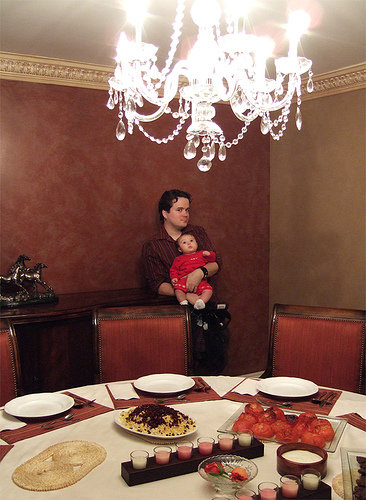<image>
Is there a chair to the left of the baby? Yes. From this viewpoint, the chair is positioned to the left side relative to the baby. 